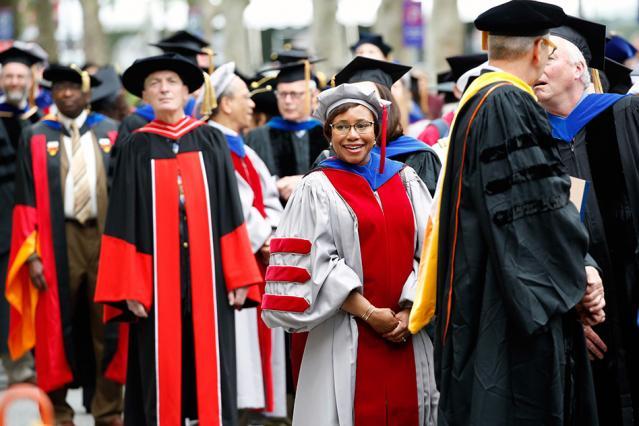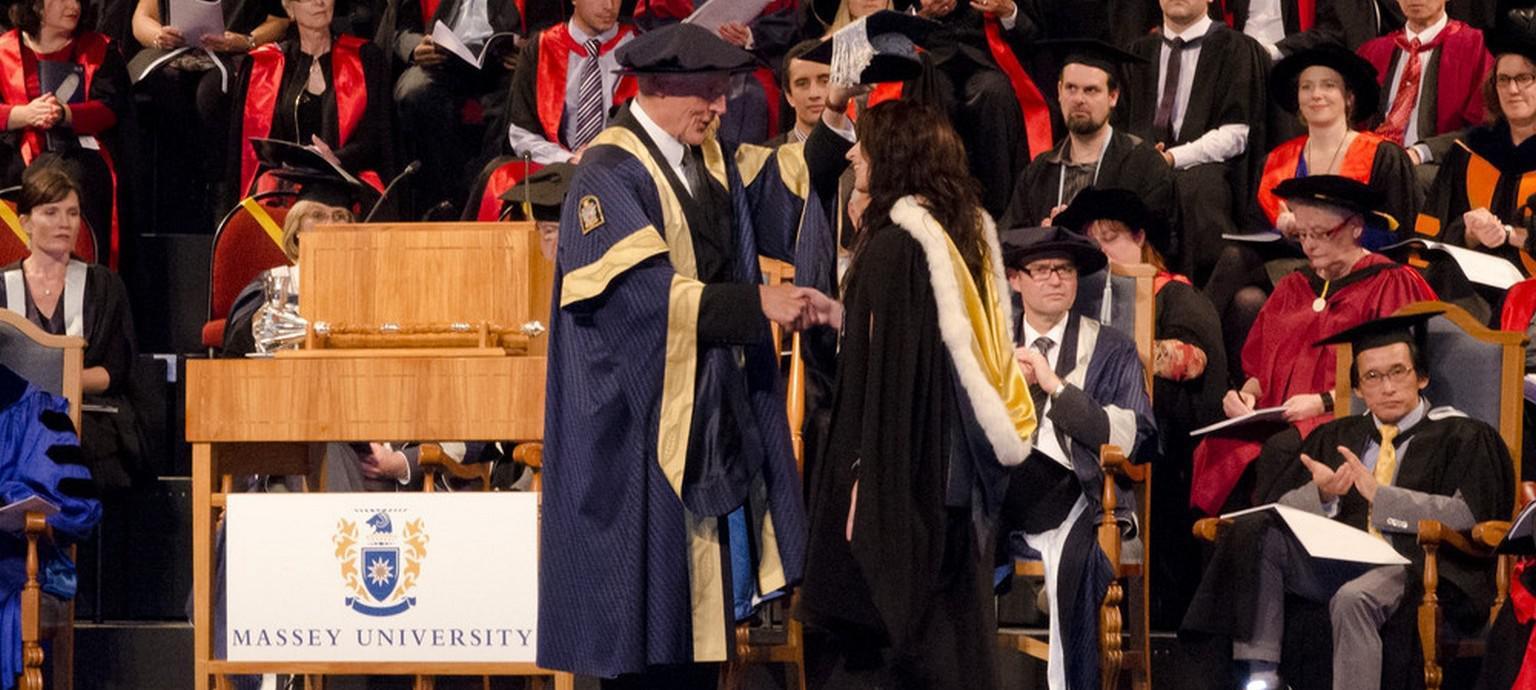The first image is the image on the left, the second image is the image on the right. Considering the images on both sides, is "Right image shows at least one person in a dark red graduation gown with black stripes on the sleeves." valid? Answer yes or no. No. 